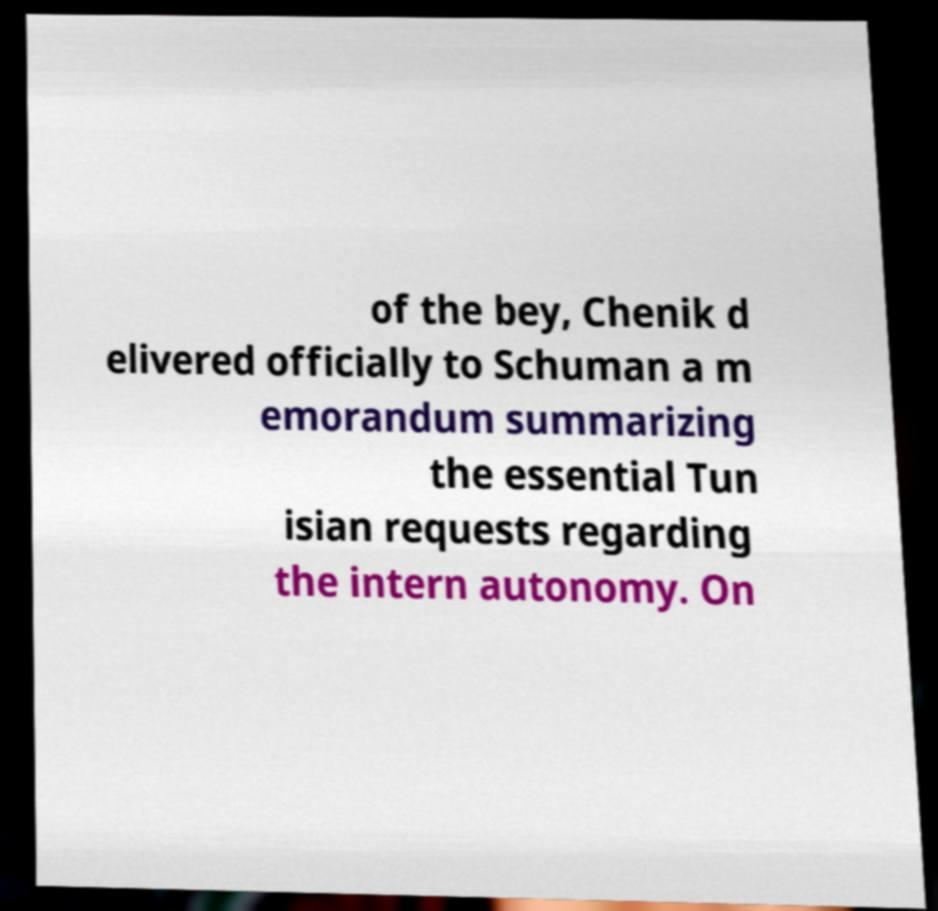I need the written content from this picture converted into text. Can you do that? of the bey, Chenik d elivered officially to Schuman a m emorandum summarizing the essential Tun isian requests regarding the intern autonomy. On 